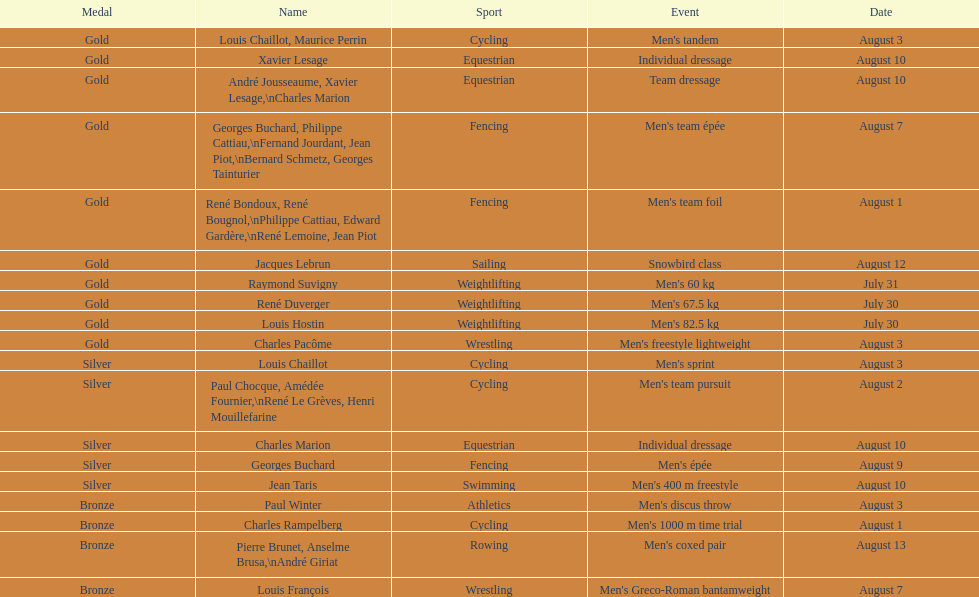What's the cumulative count of gold medals earned in weightlifting? 3. 